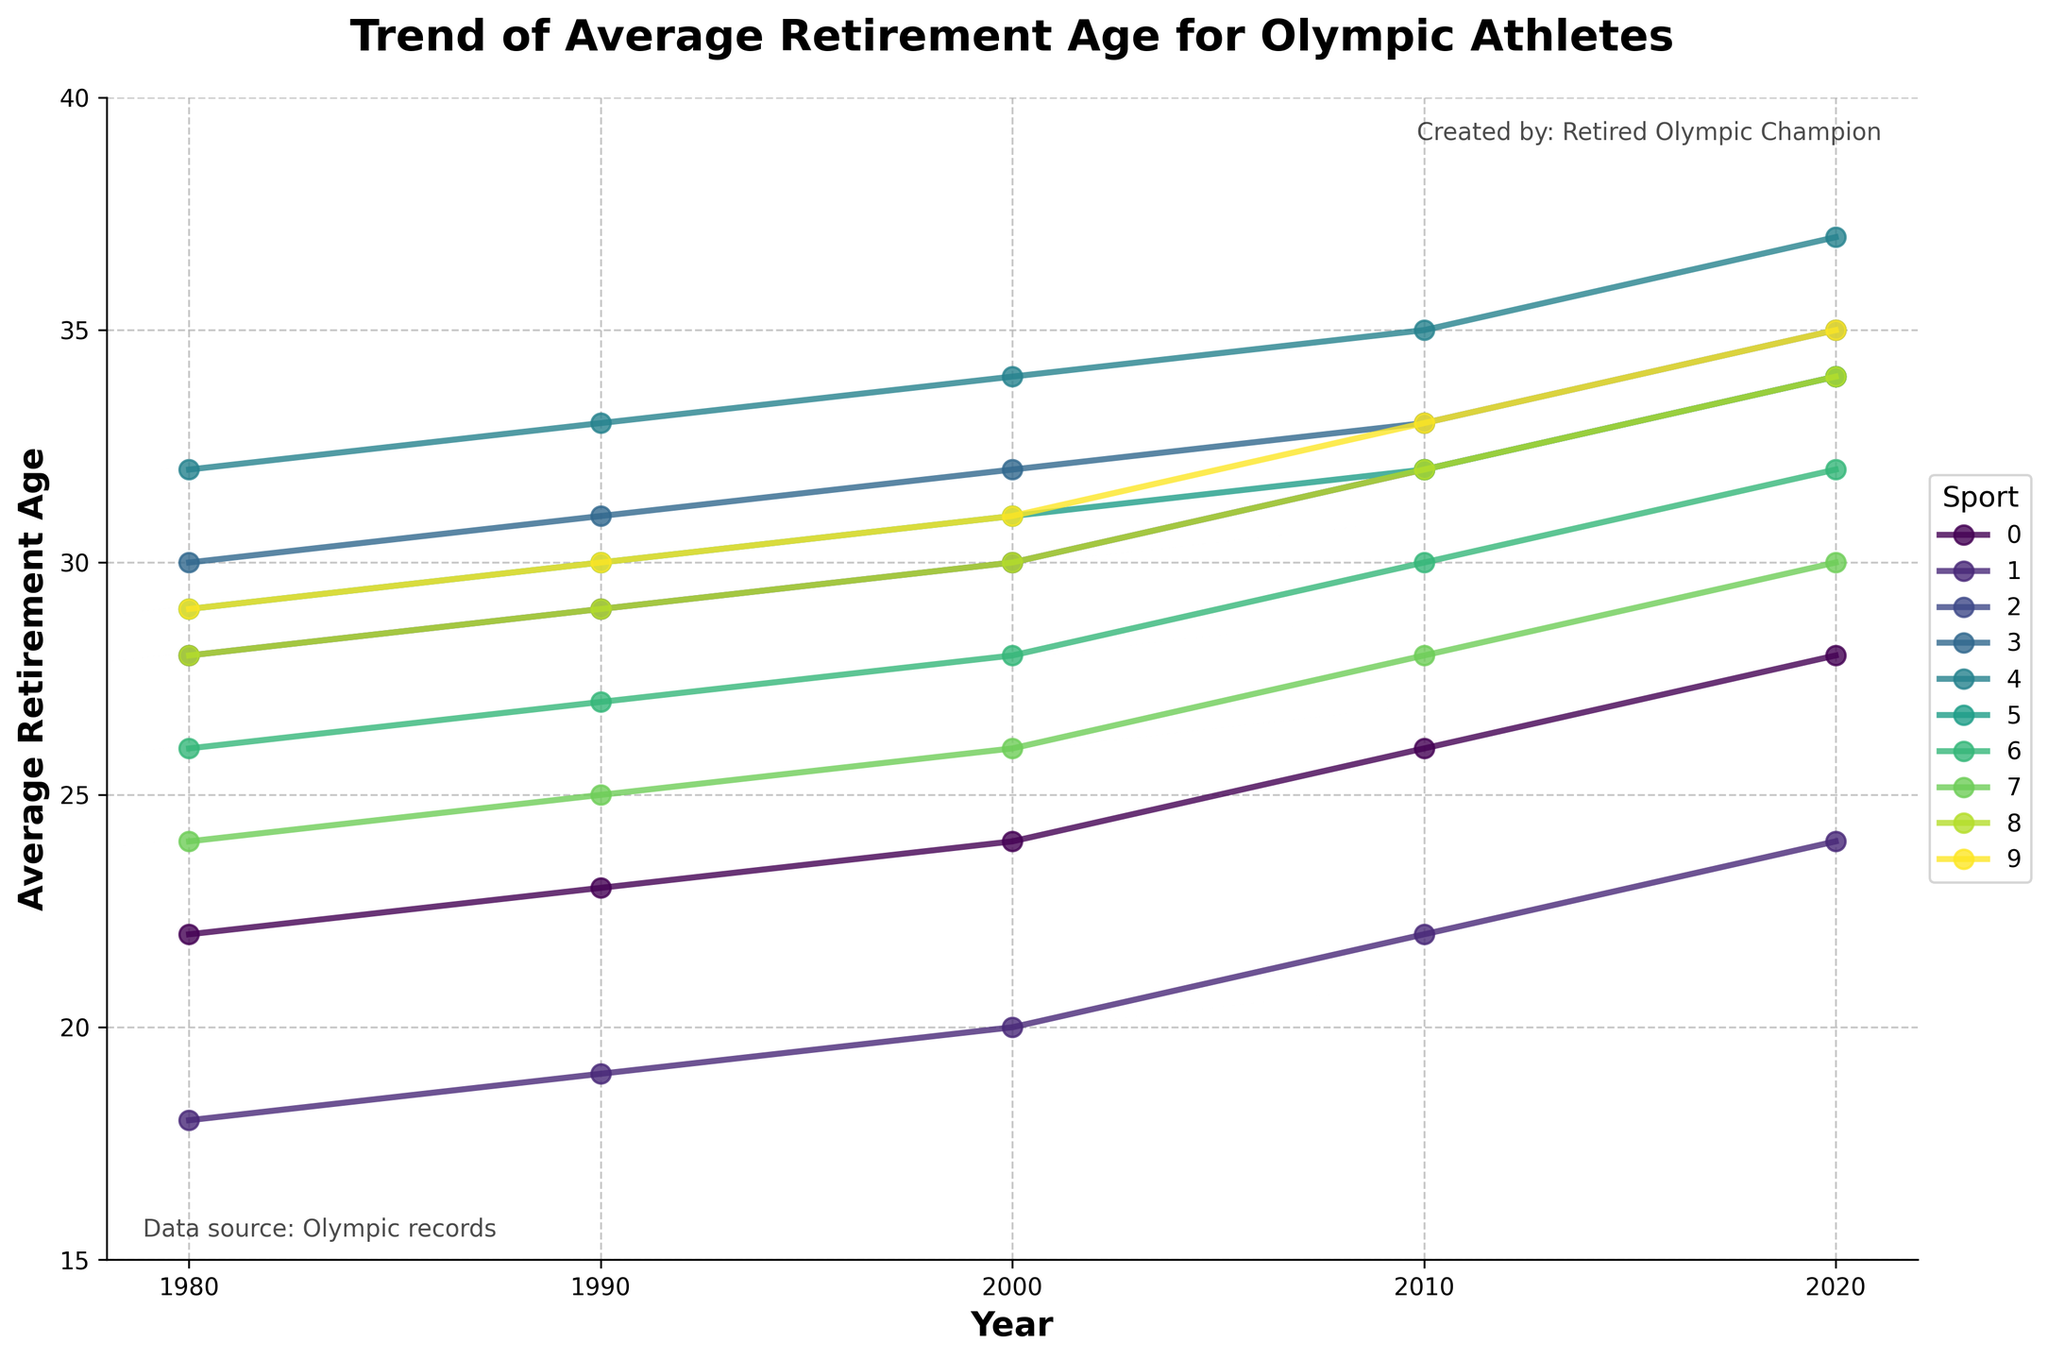What's the trend of the average retirement age for Olympic swimmers from 1980 to 2020? From the line chart, locate the data points corresponding to swimming for each decade. In 1980, the retirement age is 22, in 1990 it's 23, in 2000 it's 24, in 2010 it's 26, and in 2020 it's 28. Thus, the average retirement age for swimmers increased over these years.
Answer: Increasing Which sport showed the greatest increase in the average retirement age from 1980 to 2020? To determine this, subtract the 1980 value from the 2020 value for each sport and find the maximum difference. Swimming (28-22=6), Gymnastics (24-18=6), Track and Field (34-28=6), Tennis (35-30=5), Basketball (37-32=5), Weightlifting (34-29=5), Boxing (32-26=6), Diving (30-24=6), Rowing (34-28=6), Cycling (35-29=6). Since multiple sports show the greatest increase (6 years), the answer includes all these sports.
Answer: Swimming, Gymnastics, Track and Field, Boxing, Diving, Rowing, Cycling By how many years did the average retirement age for boxers increase between 1990 and 2000? Identify the values for boxing at 1990 and 2000 from the chart. The retirement age in 1990 is 27 and in 2000 is 28. Subtract the 1990 value from the 2000 value to find the increase: 28 - 27 = 1 year.
Answer: 1 year Which sport had the highest average retirement age in 2020? Look at the data points for all sports in 2020. Tennis and Cycling both have the highest value with an average retirement age of 35.
Answer: Tennis and Cycling What is the difference in the average retirement age between Track and Field athletes and Gymnasts in 2010? Locate the retirement age for Track and Field (32) and Gymnastics (22) in 2010 from the chart. Subtract the Gymnastics value from the Track and Field value: 32 - 22 = 10.
Answer: 10 Compare the average retirement age trend lines for Basketball and Diving. Which sport shows a steadier increase? Visualize the slope of the trend lines for both sports from 1980 to 2020. Basketball steadily increases every decade from 32 to 37 with consistent steps of 1 year. Diving increases more variably, from 24 to 30 with varying steps. Thus, Basketball shows a steadier increase.
Answer: Basketball In which decade did Rowing athletes show the significant change in their average retirement age? Observe the trend line for Rowing. The value changes by 1 year from 1980 to 2010, but it increases by 2 years from 2010 (32) to 2020 (34). Thus, the significant change occurred between 2010 and 2020.
Answer: 2010 to 2020 What was the average retirement age for weightlifters in 1990, and how does it compare to the average in 2020? Find the values for Weightlifting in 1990 and 2020 from the chart. The value in 1990 is 30 and in 2020 is 34. Compare the two values: 34 - 30 = 4 years difference.
Answer: 4 years How did the retirement age trend for Tennis compare with the overall trend for all sports shown? Compare the Tennis trend line with other sports’ average trend lines. Tennis shows a consistent and gradual increase from 30 in 1980 to 35 in 2020. This is similar to most sports shown which generally show an incremental increase in retirement age over the years.
Answer: Similar incremental trend 